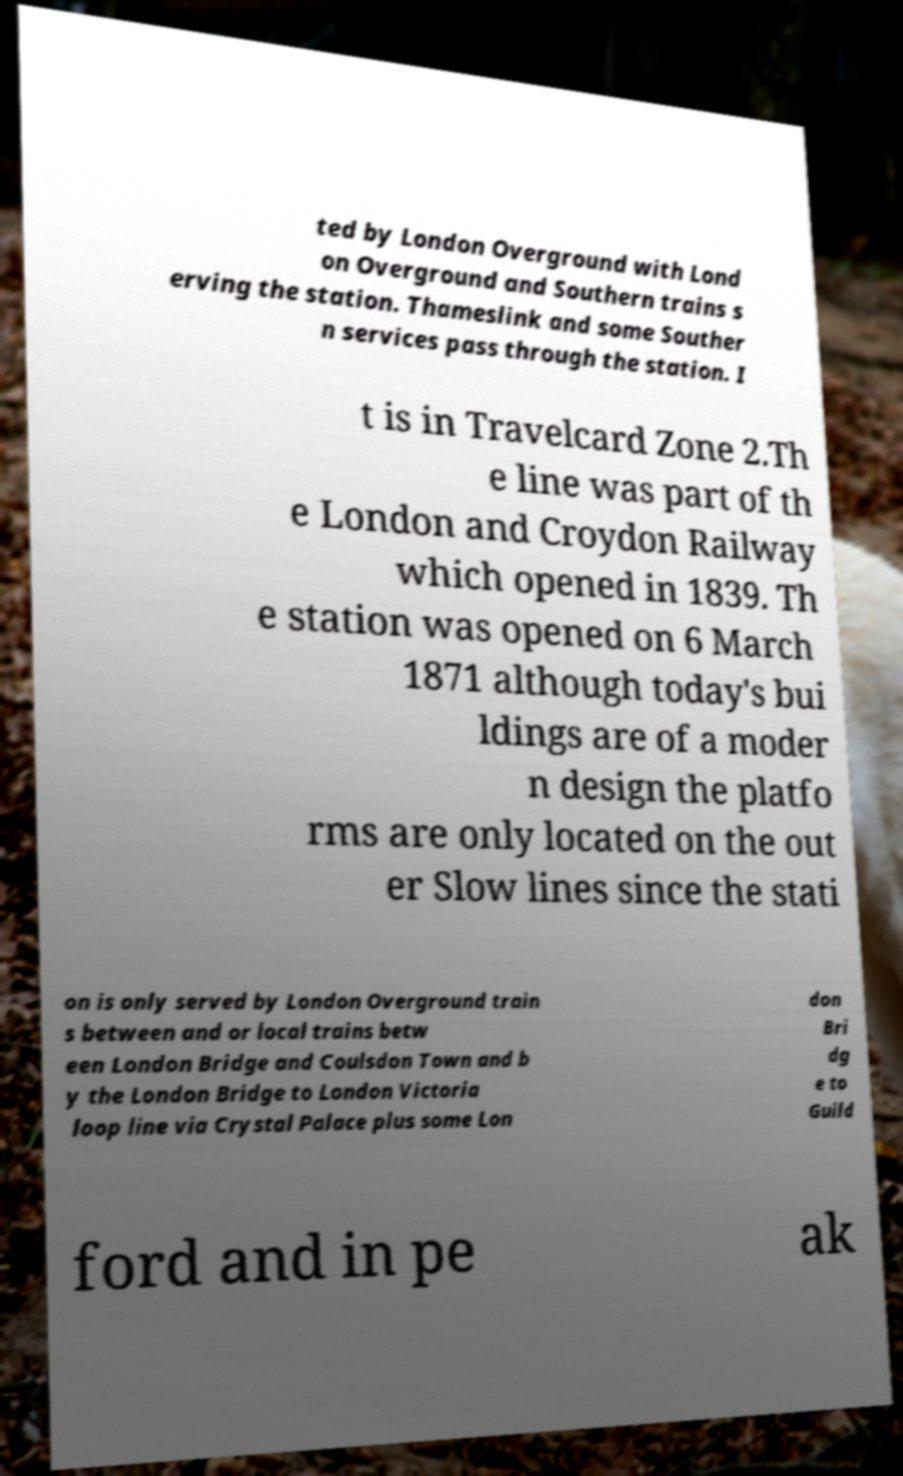Please read and relay the text visible in this image. What does it say? ted by London Overground with Lond on Overground and Southern trains s erving the station. Thameslink and some Souther n services pass through the station. I t is in Travelcard Zone 2.Th e line was part of th e London and Croydon Railway which opened in 1839. Th e station was opened on 6 March 1871 although today's bui ldings are of a moder n design the platfo rms are only located on the out er Slow lines since the stati on is only served by London Overground train s between and or local trains betw een London Bridge and Coulsdon Town and b y the London Bridge to London Victoria loop line via Crystal Palace plus some Lon don Bri dg e to Guild ford and in pe ak 